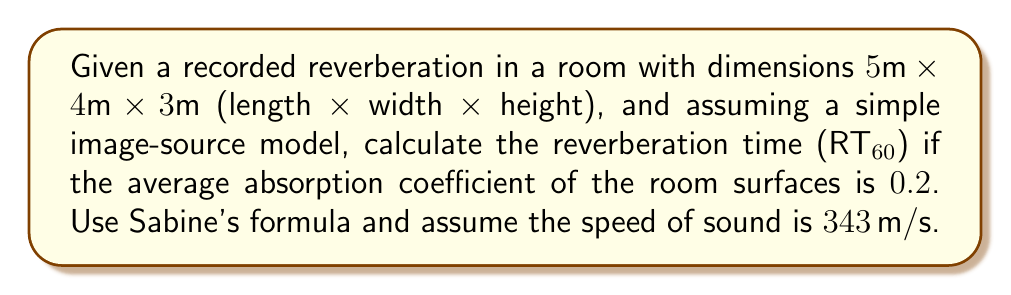Teach me how to tackle this problem. To solve this problem, we'll use Sabine's formula for reverberation time and follow these steps:

1. Calculate the total surface area of the room:
   $$S = 2(lw + lh + wh)$$
   $$S = 2(5 \cdot 4 + 5 \cdot 3 + 4 \cdot 3) = 2(20 + 15 + 12) = 2(47) = 94 \text{ m}^2$$

2. Calculate the volume of the room:
   $$V = l \cdot w \cdot h = 5 \cdot 4 \cdot 3 = 60 \text{ m}^3$$

3. Use Sabine's formula to calculate RT60:
   $$RT60 = \frac{0.161 \cdot V}{\alpha \cdot S}$$
   
   Where:
   - $V$ is the volume of the room in cubic meters
   - $\alpha$ is the average absorption coefficient
   - $S$ is the total surface area in square meters

4. Substitute the values into the formula:
   $$RT60 = \frac{0.161 \cdot 60}{0.2 \cdot 94} = \frac{9.66}{18.8} \approx 0.5138 \text{ seconds}$$

5. Round the result to two decimal places:
   $$RT60 \approx 0.51 \text{ seconds}$$

This calculated RT60 value represents the time it takes for the sound level to decrease by 60 dB after the sound source is stopped. In audio software development, this parameter is crucial for accurately simulating room acoustics or applying artificial reverberation effects.
Answer: $RT60 \approx 0.51 \text{ seconds}$ 